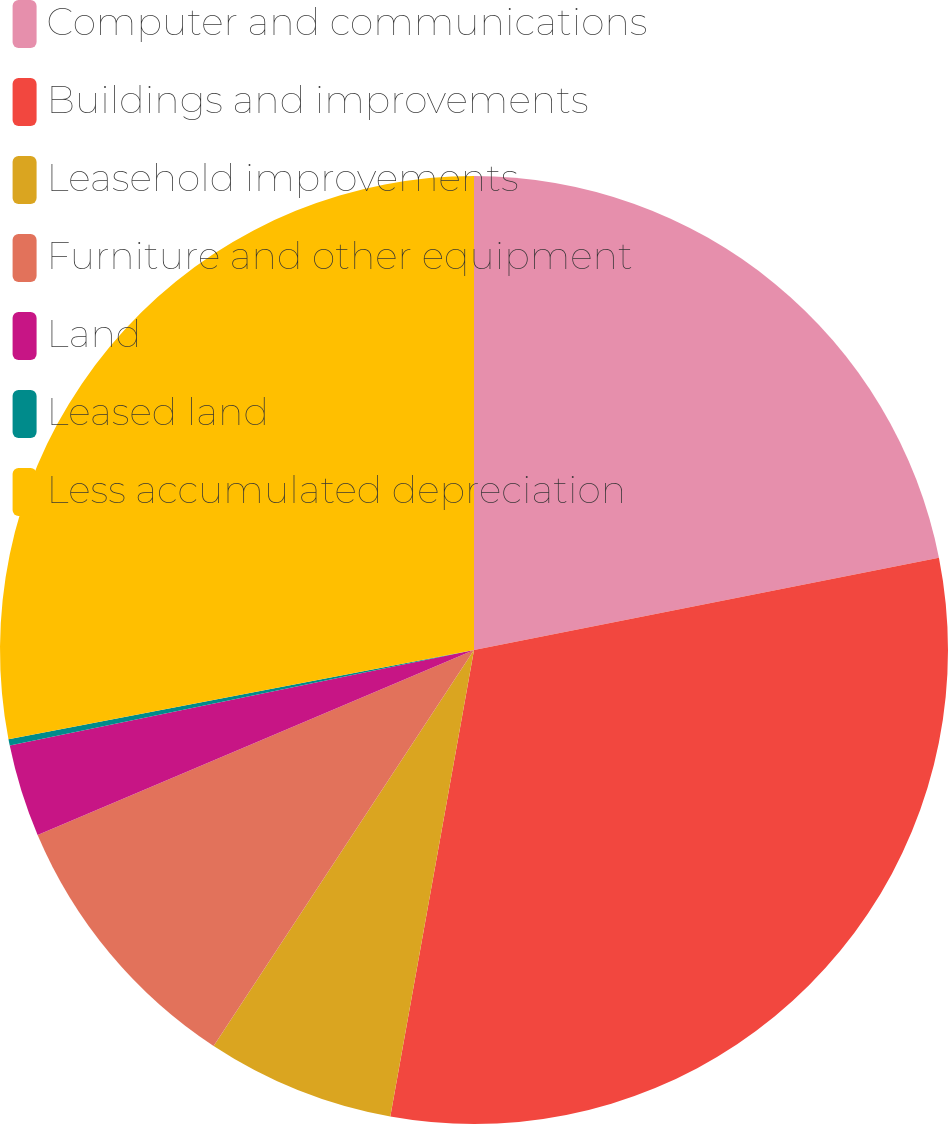Convert chart. <chart><loc_0><loc_0><loc_500><loc_500><pie_chart><fcel>Computer and communications<fcel>Buildings and improvements<fcel>Leasehold improvements<fcel>Furniture and other equipment<fcel>Land<fcel>Leased land<fcel>Less accumulated depreciation<nl><fcel>21.88%<fcel>30.94%<fcel>6.43%<fcel>9.36%<fcel>3.15%<fcel>0.22%<fcel>28.01%<nl></chart> 